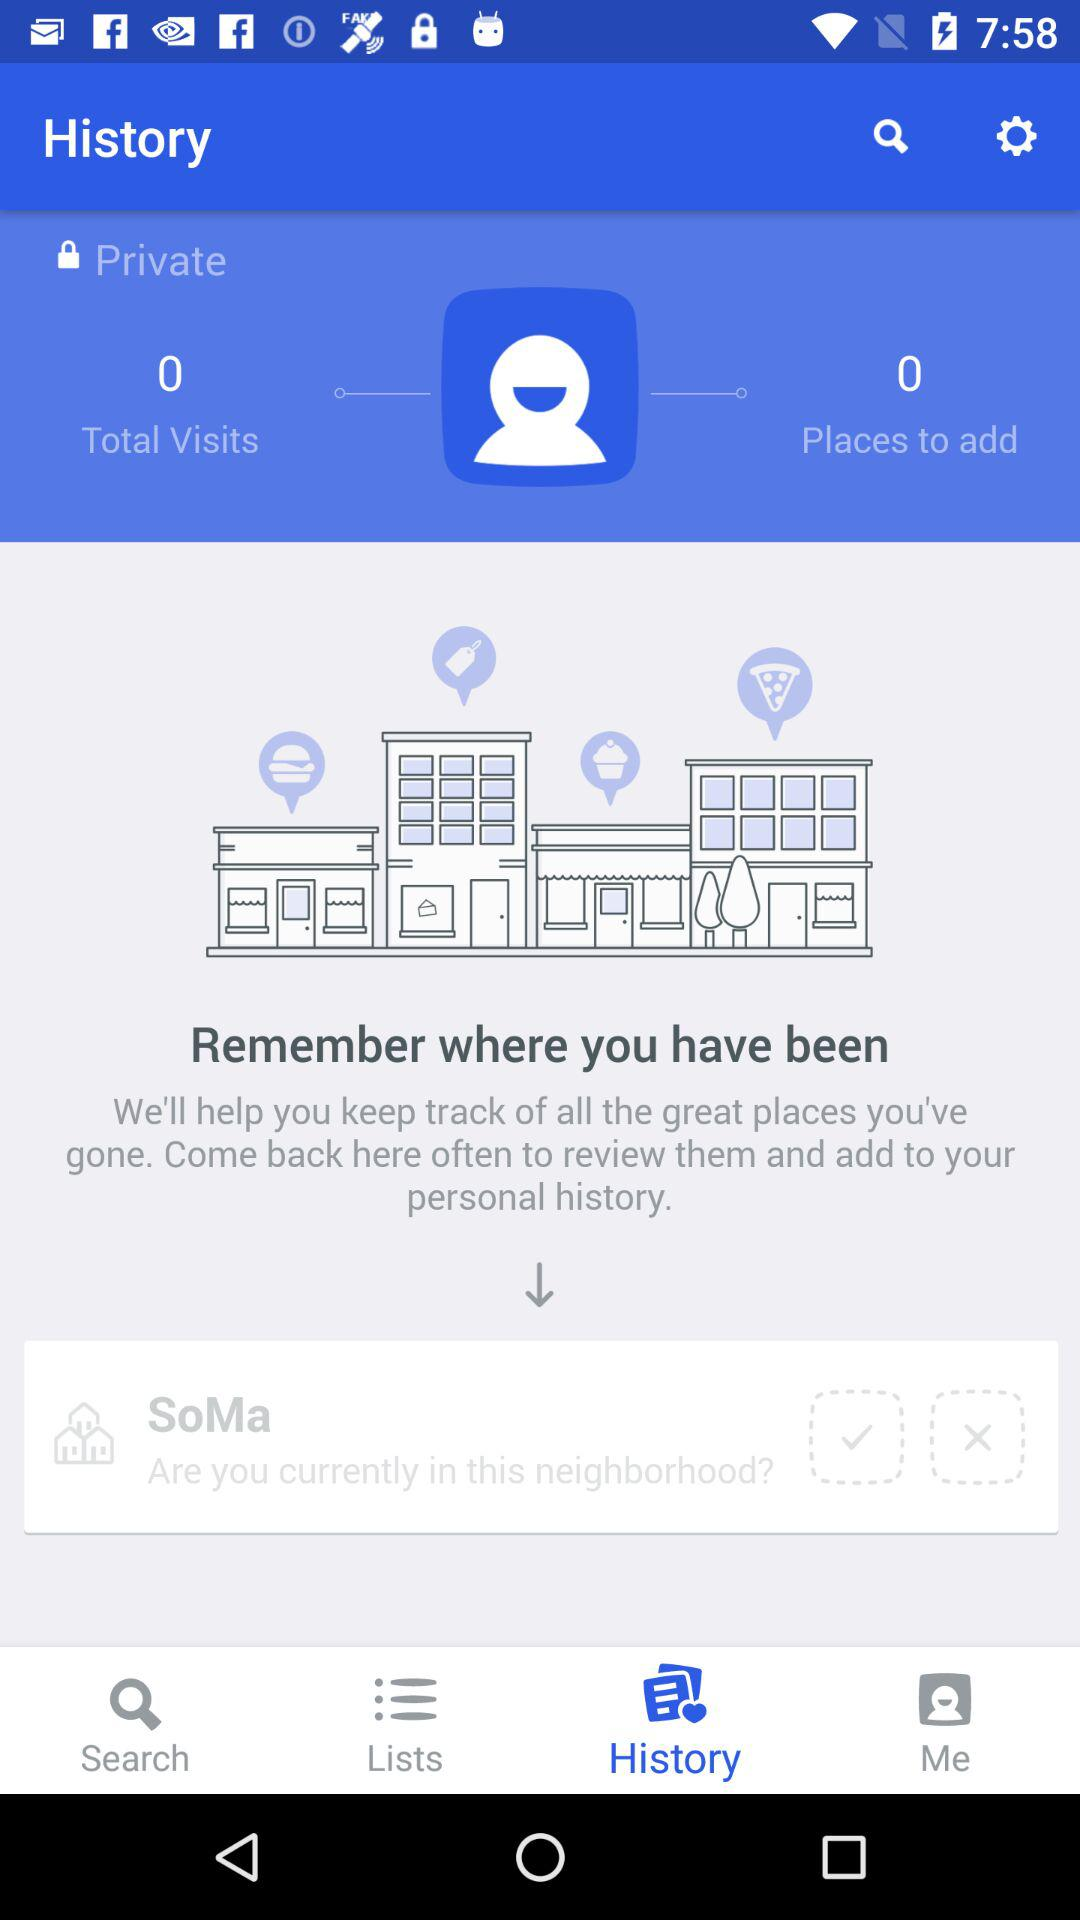How many places have you been to?
Answer the question using a single word or phrase. 0 